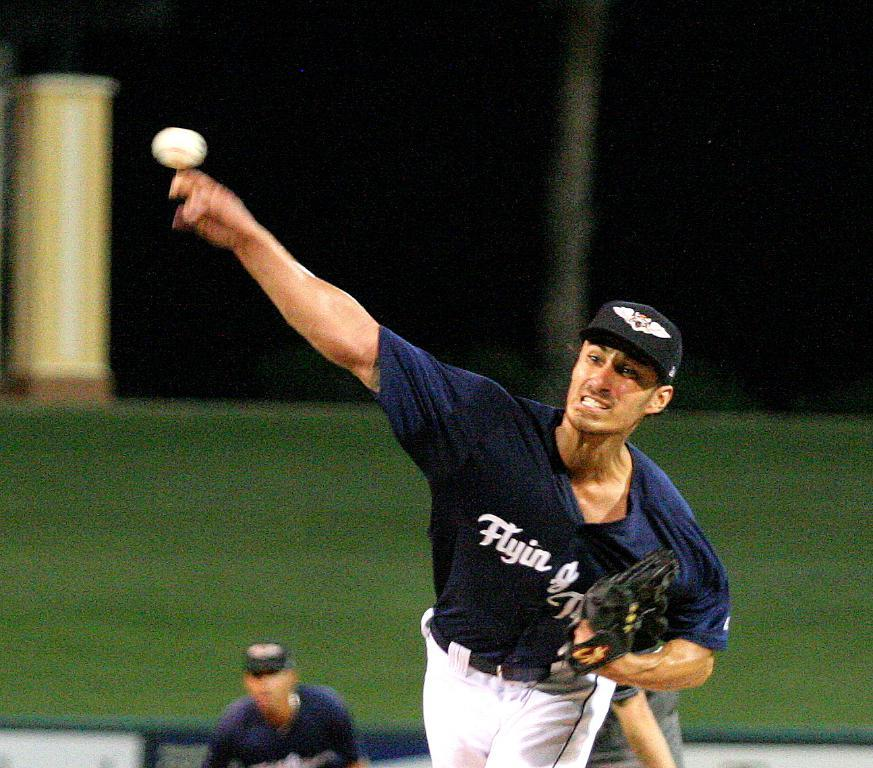<image>
Render a clear and concise summary of the photo. a baseball pitcher from the team Flyin baseball team 